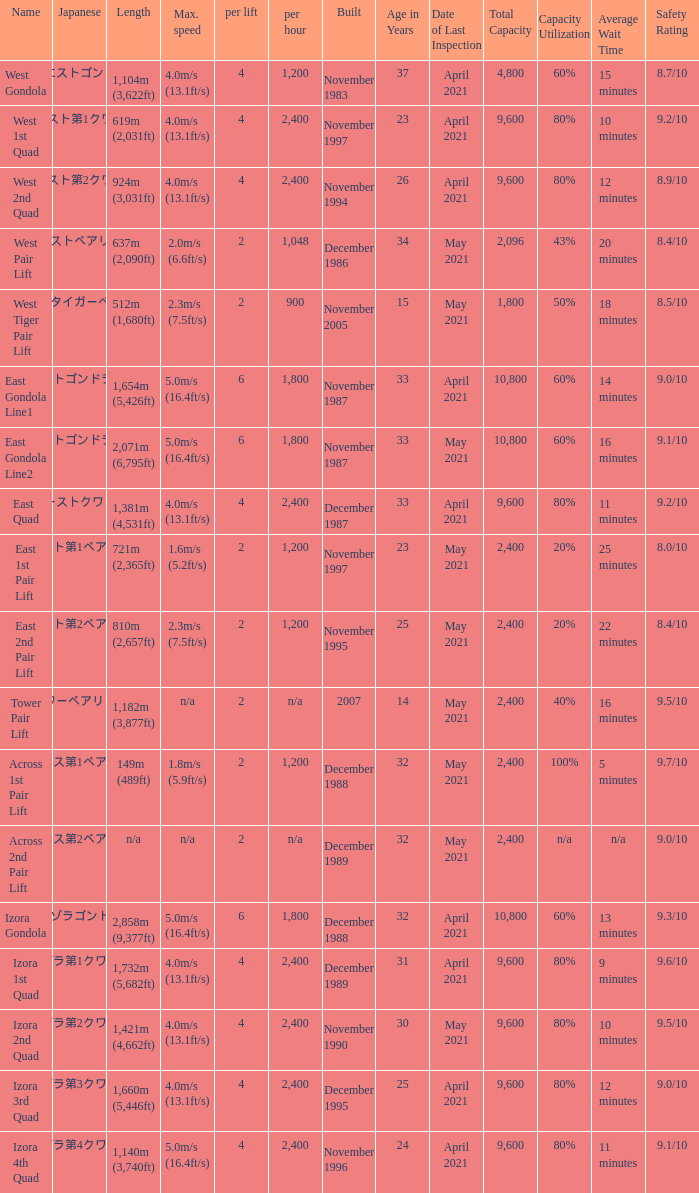How heavy is the  maximum 6.0. 